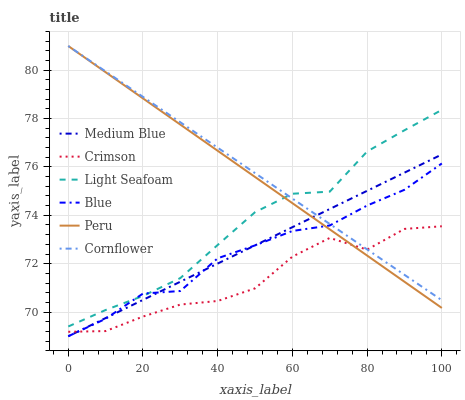Does Crimson have the minimum area under the curve?
Answer yes or no. Yes. Does Cornflower have the maximum area under the curve?
Answer yes or no. Yes. Does Medium Blue have the minimum area under the curve?
Answer yes or no. No. Does Medium Blue have the maximum area under the curve?
Answer yes or no. No. Is Medium Blue the smoothest?
Answer yes or no. Yes. Is Crimson the roughest?
Answer yes or no. Yes. Is Cornflower the smoothest?
Answer yes or no. No. Is Cornflower the roughest?
Answer yes or no. No. Does Cornflower have the lowest value?
Answer yes or no. No. Does Peru have the highest value?
Answer yes or no. Yes. Does Medium Blue have the highest value?
Answer yes or no. No. Is Medium Blue less than Light Seafoam?
Answer yes or no. Yes. Is Light Seafoam greater than Crimson?
Answer yes or no. Yes. Does Cornflower intersect Blue?
Answer yes or no. Yes. Is Cornflower less than Blue?
Answer yes or no. No. Is Cornflower greater than Blue?
Answer yes or no. No. Does Medium Blue intersect Light Seafoam?
Answer yes or no. No. 